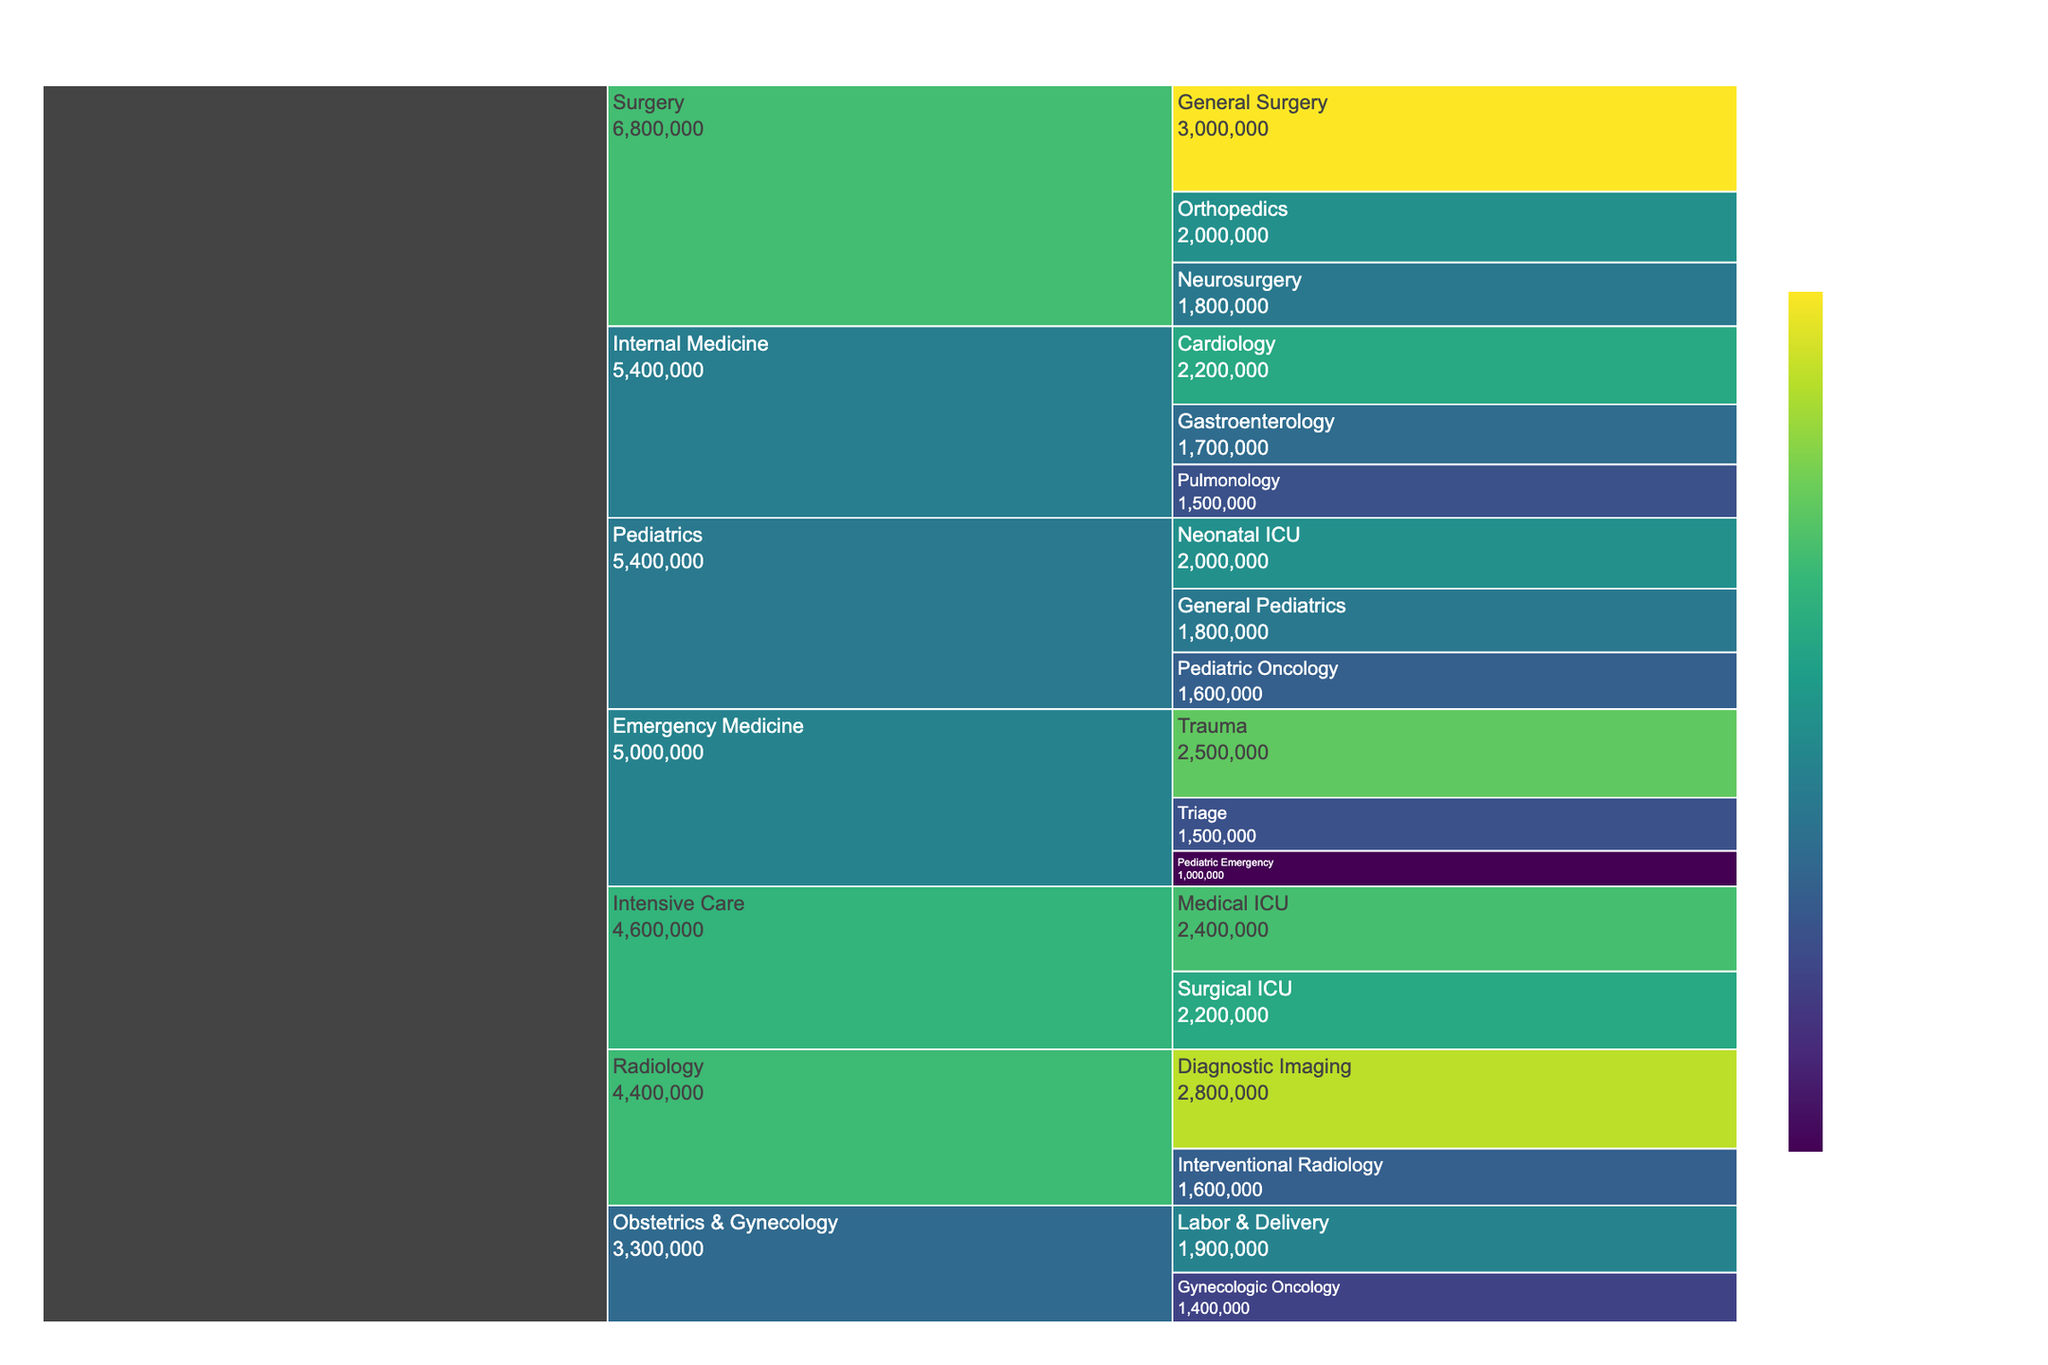What is the title of the icicle chart? The title of the chart can be found at the top of the figure, usually displayed prominently to indicate what the visualization is about.
Answer: Hospital Resource Allocation Across Departments and Units Which department receives the highest total budget allocation? To find the department with the highest total budget allocation, sum up the budget allocations of all units within each department and compare the totals. The department with the highest sum is the answer.
Answer: Surgery What is the total budget allocation for the Emergency Medicine department? Sum up the budget allocations of all units within the Emergency Medicine department: Trauma ($2,500,000) + Triage ($1,500,000) + Pediatric Emergency ($1,000,000) = $5,000,000.
Answer: $5,000,000 Which unit has the lowest budget allocation in the Pediatrics department? Compare the budget allocations of all units within the Pediatrics department to find the lowest value: Neonatal ICU ($2,000,000), General Pediatrics ($1,800,000), Pediatric Oncology ($1,600,000).
Answer: Pediatric Oncology Across all departments, which unit has the highest budget allocation? Identify and compare the budget allocations of all units across all departments to find the highest value. Diagnostic Imaging in Radiology has a budget allocation of $2,800,000, which is the highest individual unit budget allocation.
Answer: Diagnostic Imaging Are there any units in the Obstetrics & Gynecology department with a budget allocation greater than $1,500,000? Examine the budget allocations for units in the Obstetrics & Gynecology department. Both Labor & Delivery ($1,900,000) and Gynecologic Oncology ($1,400,000) are listed. Only Labor & Delivery exceeds $1,500,000.
Answer: Yes What is the difference in budget allocation between the Medical ICU and the Surgical ICU? Subtract the budget allocation of the Surgical ICU ($2,200,000) from the budget allocation of the Medical ICU ($2,400,000): $2,400,000 - $2,200,000 = $200,000.
Answer: $200,000 How many units have a budget allocation of at least $2,000,000? Count the units with a budget allocation of $2,000,000 or more: Trauma, General Surgery, Diagnostic Imaging, Medical ICU, and Cardiology each have budget allocations meeting or exceeding $2,000,000. There are 5 such units.
Answer: 5 Which department has the smallest total budget allocation? Sum up the budget allocations for each department and compare the totals. Obstetrics & Gynecology has totals of $1,900,000 + $1,400,000 = $3,300,000, which is the smallest total compared to other departments.
Answer: Obstetrics & Gynecology What is the average budget allocation for units in the Internal Medicine department? Sum up the budget allocations for all Internal Medicine units: Cardiology ($2,200,000) + Gastroenterology ($1,700,000) + Pulmonology ($1,500,000) = $5,400,000. Then, divide by the number of units (3): $5,400,000 / 3 = $1,800,000.
Answer: $1,800,000 